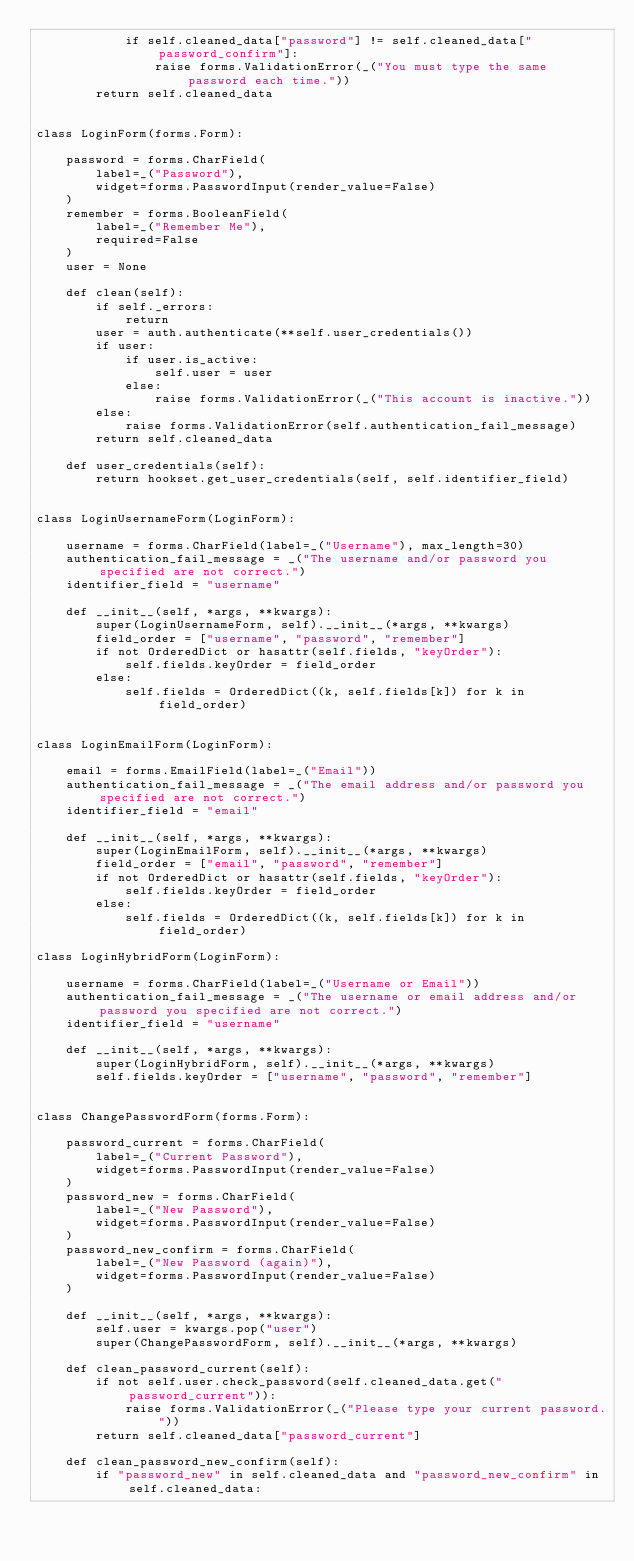<code> <loc_0><loc_0><loc_500><loc_500><_Python_>            if self.cleaned_data["password"] != self.cleaned_data["password_confirm"]:
                raise forms.ValidationError(_("You must type the same password each time."))
        return self.cleaned_data


class LoginForm(forms.Form):

    password = forms.CharField(
        label=_("Password"),
        widget=forms.PasswordInput(render_value=False)
    )
    remember = forms.BooleanField(
        label=_("Remember Me"),
        required=False
    )
    user = None

    def clean(self):
        if self._errors:
            return
        user = auth.authenticate(**self.user_credentials())
        if user:
            if user.is_active:
                self.user = user
            else:
                raise forms.ValidationError(_("This account is inactive."))
        else:
            raise forms.ValidationError(self.authentication_fail_message)
        return self.cleaned_data

    def user_credentials(self):
        return hookset.get_user_credentials(self, self.identifier_field)


class LoginUsernameForm(LoginForm):

    username = forms.CharField(label=_("Username"), max_length=30)
    authentication_fail_message = _("The username and/or password you specified are not correct.")
    identifier_field = "username"

    def __init__(self, *args, **kwargs):
        super(LoginUsernameForm, self).__init__(*args, **kwargs)
        field_order = ["username", "password", "remember"]
        if not OrderedDict or hasattr(self.fields, "keyOrder"):
            self.fields.keyOrder = field_order
        else:
            self.fields = OrderedDict((k, self.fields[k]) for k in field_order)


class LoginEmailForm(LoginForm):

    email = forms.EmailField(label=_("Email"))
    authentication_fail_message = _("The email address and/or password you specified are not correct.")
    identifier_field = "email"

    def __init__(self, *args, **kwargs):
        super(LoginEmailForm, self).__init__(*args, **kwargs)
        field_order = ["email", "password", "remember"]
        if not OrderedDict or hasattr(self.fields, "keyOrder"):
            self.fields.keyOrder = field_order
        else:
            self.fields = OrderedDict((k, self.fields[k]) for k in field_order)

class LoginHybridForm(LoginForm):
    
    username = forms.CharField(label=_("Username or Email"))
    authentication_fail_message = _("The username or email address and/or password you specified are not correct.")
    identifier_field = "username"
    
    def __init__(self, *args, **kwargs):
        super(LoginHybridForm, self).__init__(*args, **kwargs)
        self.fields.keyOrder = ["username", "password", "remember"]


class ChangePasswordForm(forms.Form):

    password_current = forms.CharField(
        label=_("Current Password"),
        widget=forms.PasswordInput(render_value=False)
    )
    password_new = forms.CharField(
        label=_("New Password"),
        widget=forms.PasswordInput(render_value=False)
    )
    password_new_confirm = forms.CharField(
        label=_("New Password (again)"),
        widget=forms.PasswordInput(render_value=False)
    )

    def __init__(self, *args, **kwargs):
        self.user = kwargs.pop("user")
        super(ChangePasswordForm, self).__init__(*args, **kwargs)

    def clean_password_current(self):
        if not self.user.check_password(self.cleaned_data.get("password_current")):
            raise forms.ValidationError(_("Please type your current password."))
        return self.cleaned_data["password_current"]

    def clean_password_new_confirm(self):
        if "password_new" in self.cleaned_data and "password_new_confirm" in self.cleaned_data:</code> 